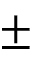<formula> <loc_0><loc_0><loc_500><loc_500>\pm</formula> 